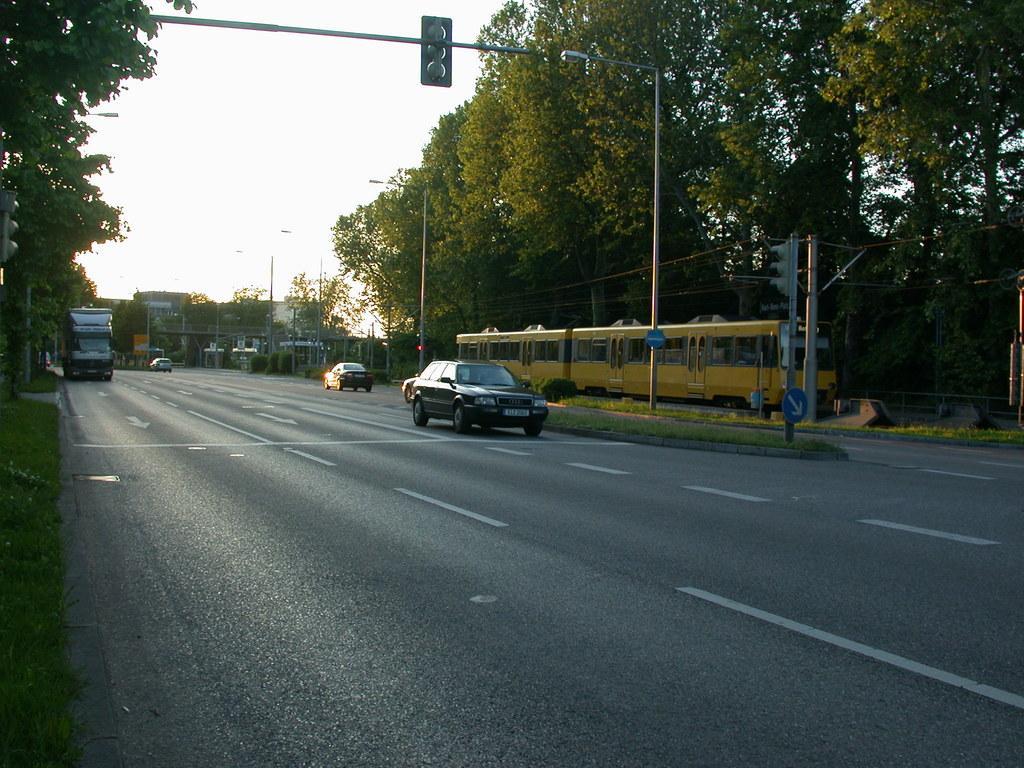Can you describe this image briefly? In the middle a car is moving on the road. At the top it's a traffic signal, in the right side there are trees. 